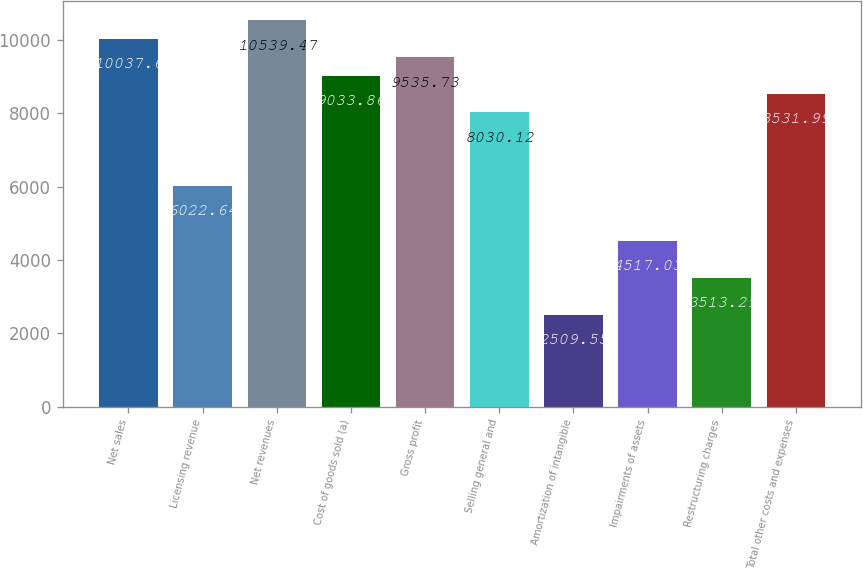Convert chart to OTSL. <chart><loc_0><loc_0><loc_500><loc_500><bar_chart><fcel>Net sales<fcel>Licensing revenue<fcel>Net revenues<fcel>Cost of goods sold (a)<fcel>Gross profit<fcel>Selling general and<fcel>Amortization of intangible<fcel>Impairments of assets<fcel>Restructuring charges<fcel>Total other costs and expenses<nl><fcel>10037.6<fcel>6022.64<fcel>10539.5<fcel>9033.86<fcel>9535.73<fcel>8030.12<fcel>2509.55<fcel>4517.03<fcel>3513.29<fcel>8531.99<nl></chart> 